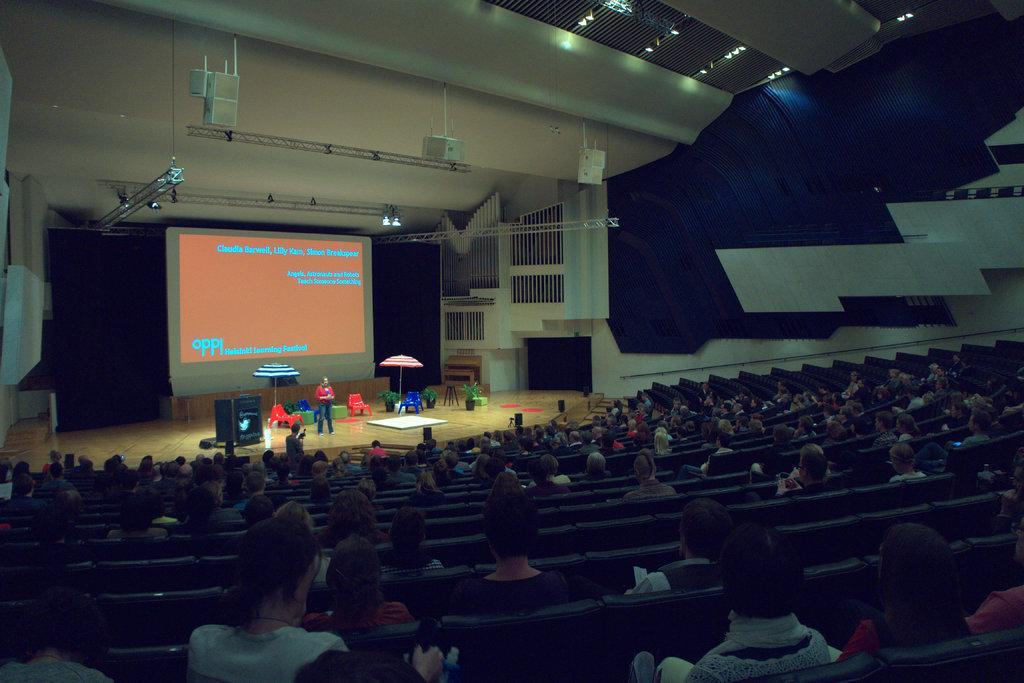Provide a one-sentence caption for the provided image. An auditorium full of people watching a powerpoint presentation organized by oppi  Helsinki Learning Festival. 